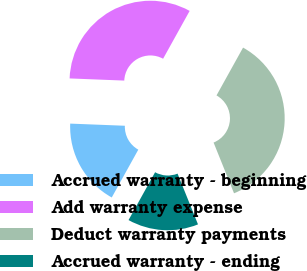Convert chart. <chart><loc_0><loc_0><loc_500><loc_500><pie_chart><fcel>Accrued warranty - beginning<fcel>Add warranty expense<fcel>Deduct warranty payments<fcel>Accrued warranty - ending<nl><fcel>17.56%<fcel>32.44%<fcel>35.84%<fcel>14.16%<nl></chart> 